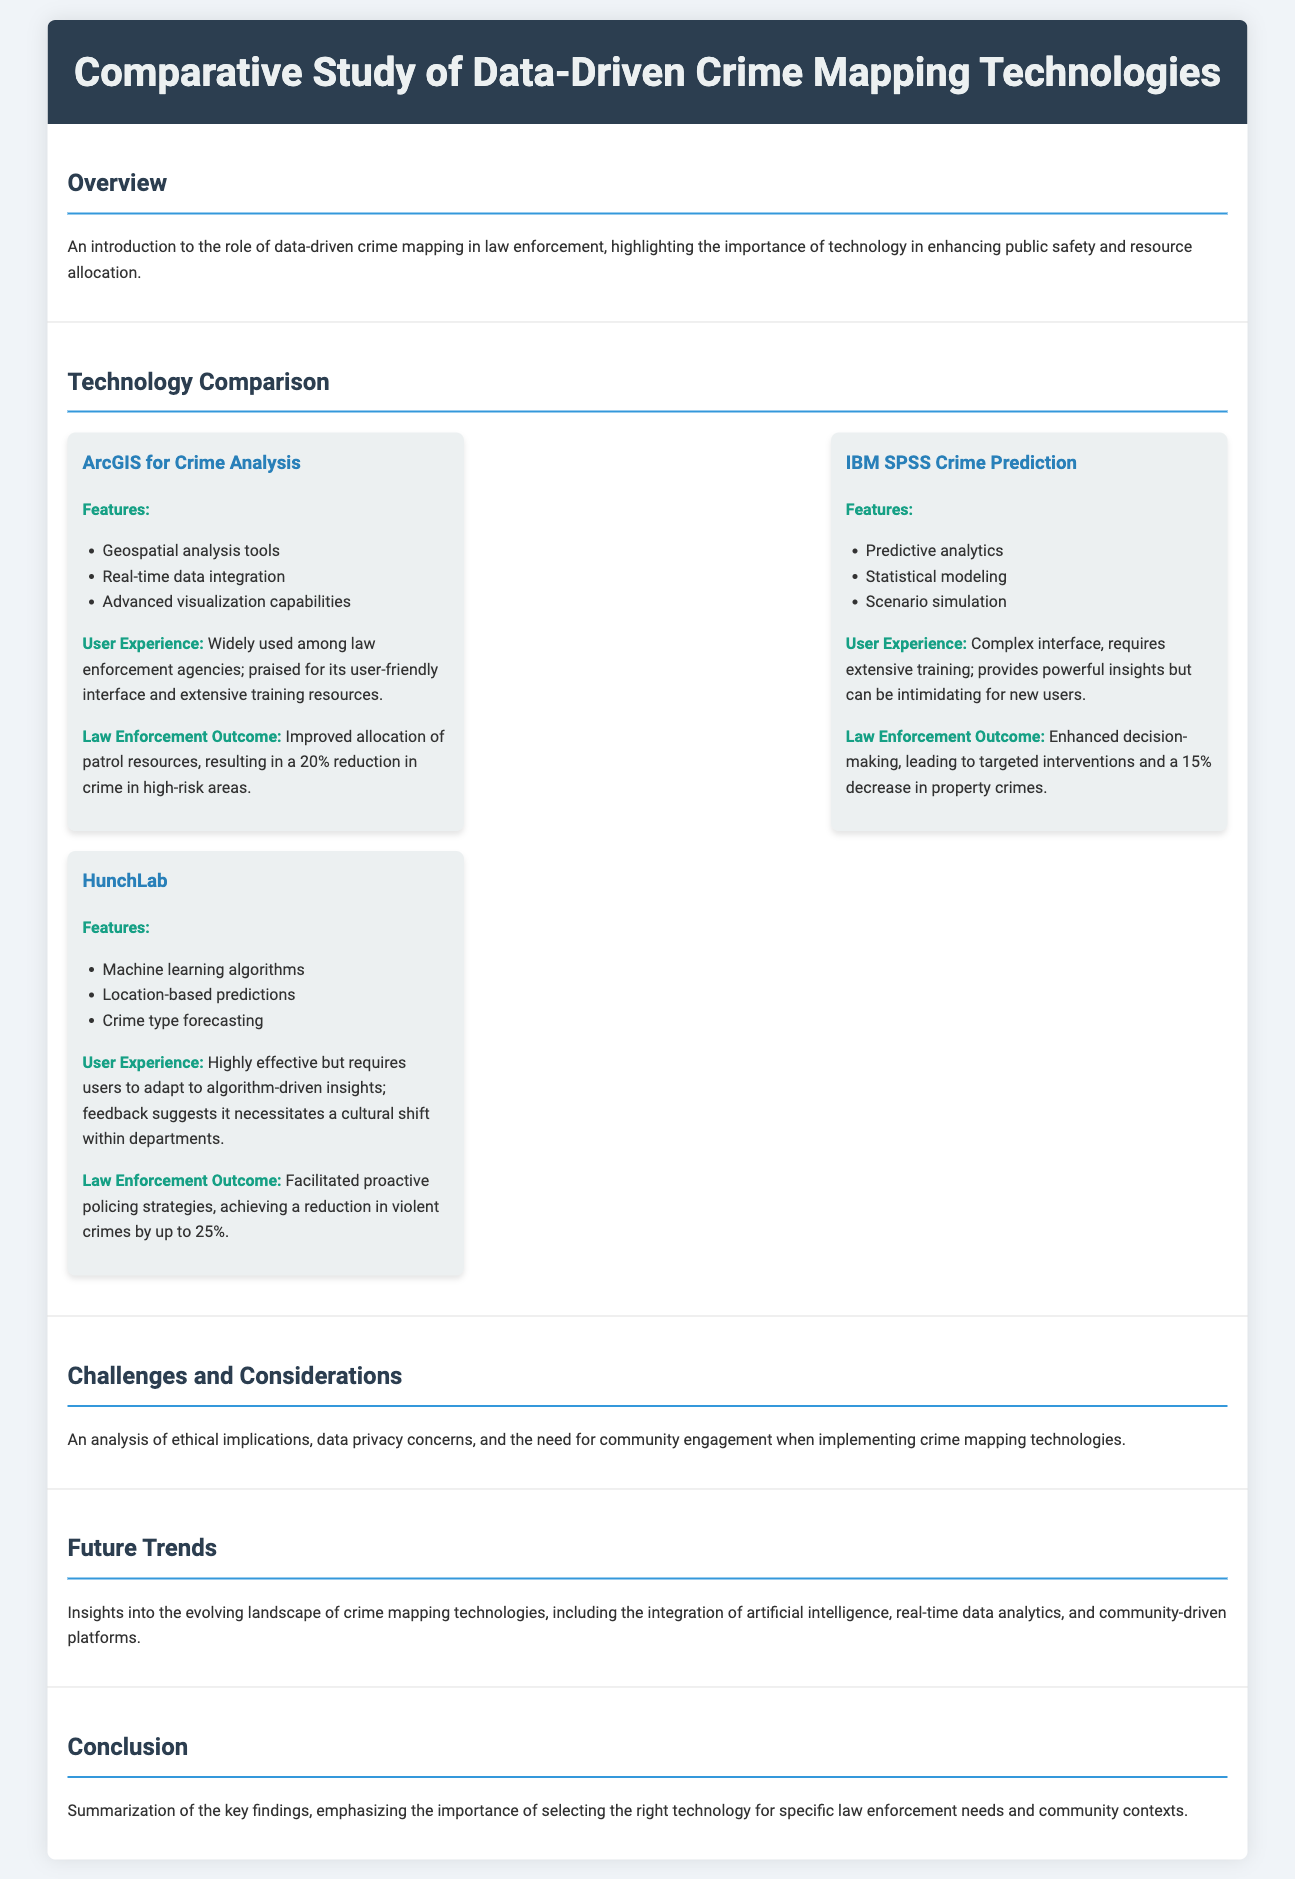What are the key features of ArcGIS for Crime Analysis? The key features of ArcGIS for Crime Analysis include geospatial analysis tools, real-time data integration, and advanced visualization capabilities.
Answer: geospatial analysis tools, real-time data integration, advanced visualization capabilities What percentage reduction in crime was reported using HunchLab? HunchLab facilitated proactive policing strategies, achieving a reduction in violent crimes by up to 25%.
Answer: 25% What is a major challenge discussed in the document? The document discusses ethical implications, data privacy concerns, and the need for community engagement as major challenges.
Answer: ethical implications How does IBM SPSS Crime Prediction impact property crimes? IBM SPSS Crime Prediction led to targeted interventions and a 15% decrease in property crimes.
Answer: 15% What user experience challenges does IBM SPSS present? IBM SPSS has a complex interface that requires extensive training, which can be intimidating for new users.
Answer: complex interface What is emphasized in the conclusion of the document? The conclusion emphasizes the importance of selecting the right technology for specific law enforcement needs and community contexts.
Answer: selecting the right technology Which technology is praised for its user-friendly interface? ArcGIS for Crime Analysis is widely praised for its user-friendly interface and extensive training resources.
Answer: ArcGIS for Crime Analysis What does the overview highlight concerning technology? The overview highlights the importance of technology in enhancing public safety and resource allocation.
Answer: enhancing public safety What does HunchLab utilize for its predictions? HunchLab utilizes machine learning algorithms for its predictions.
Answer: machine learning algorithms 